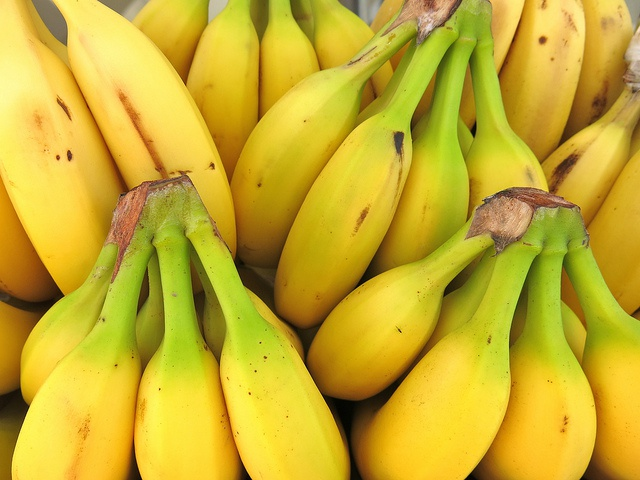Describe the objects in this image and their specific colors. I can see banana in khaki, gold, orange, and olive tones, banana in khaki, gold, and olive tones, banana in khaki, olive, and gold tones, banana in khaki, gold, and orange tones, and banana in khaki, gold, orange, and olive tones in this image. 